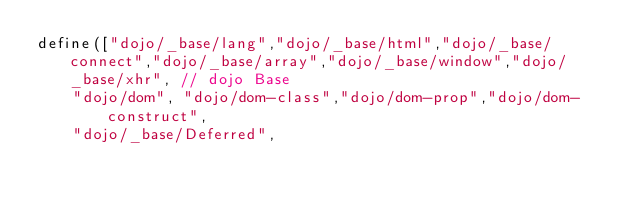Convert code to text. <code><loc_0><loc_0><loc_500><loc_500><_JavaScript_>define(["dojo/_base/lang","dojo/_base/html","dojo/_base/connect","dojo/_base/array","dojo/_base/window","dojo/_base/xhr", // dojo Base
		"dojo/dom", "dojo/dom-class","dojo/dom-prop","dojo/dom-construct",
		"dojo/_base/Deferred",</code> 